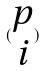<formula> <loc_0><loc_0><loc_500><loc_500>( \begin{matrix} p \\ i \end{matrix} )</formula> 